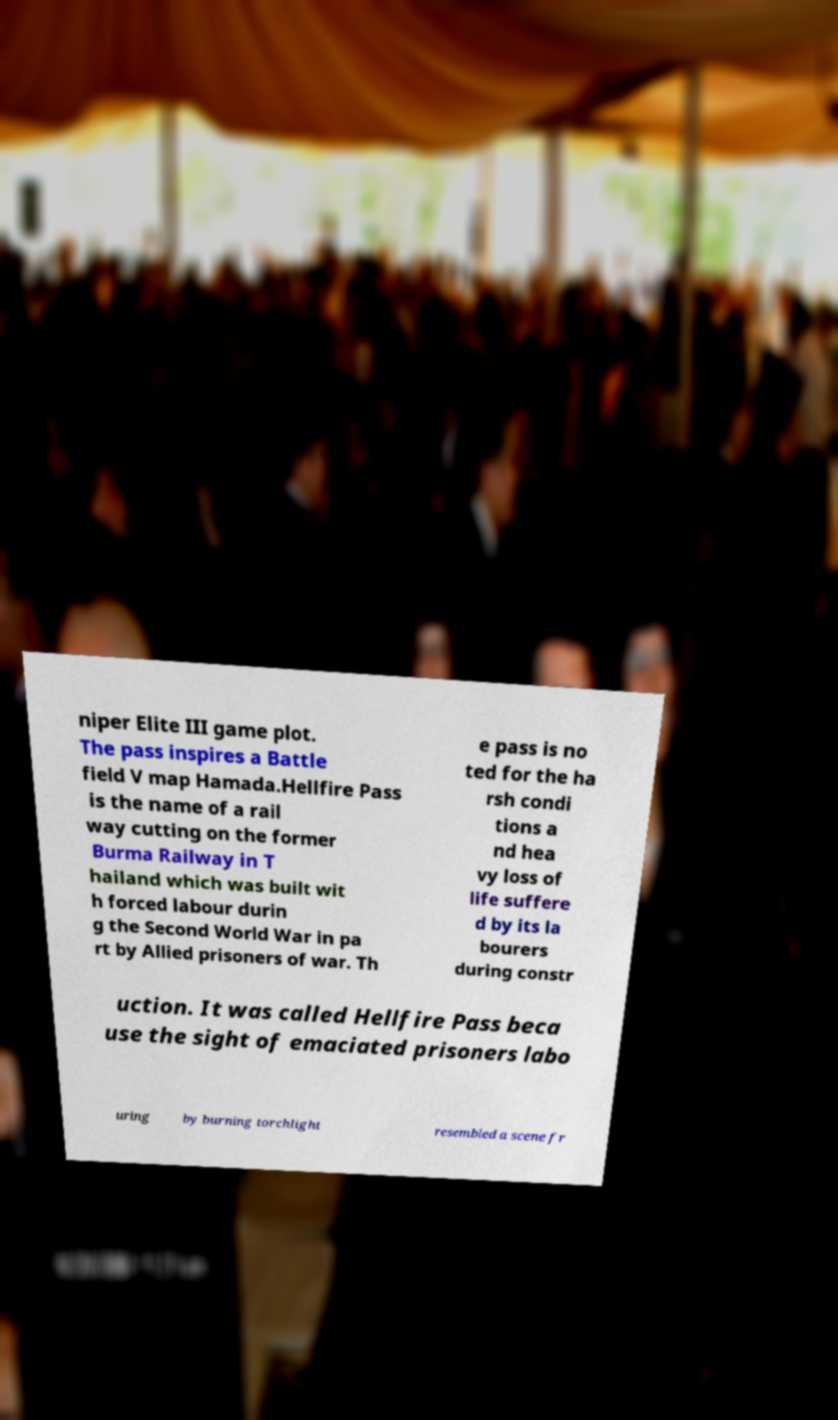What messages or text are displayed in this image? I need them in a readable, typed format. niper Elite III game plot. The pass inspires a Battle field V map Hamada.Hellfire Pass is the name of a rail way cutting on the former Burma Railway in T hailand which was built wit h forced labour durin g the Second World War in pa rt by Allied prisoners of war. Th e pass is no ted for the ha rsh condi tions a nd hea vy loss of life suffere d by its la bourers during constr uction. It was called Hellfire Pass beca use the sight of emaciated prisoners labo uring by burning torchlight resembled a scene fr 